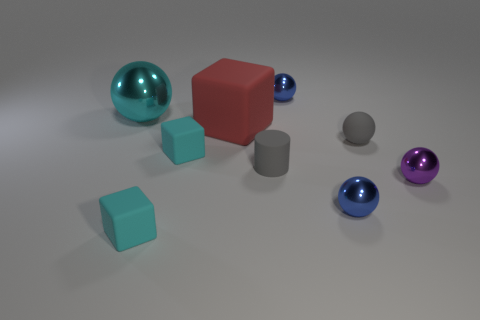Subtract all tiny gray rubber spheres. How many spheres are left? 4 Subtract all cyan balls. How many balls are left? 4 Subtract all yellow spheres. Subtract all brown cylinders. How many spheres are left? 5 Subtract all cubes. How many objects are left? 6 Add 1 red blocks. How many objects exist? 10 Subtract all large blue shiny things. Subtract all large cyan balls. How many objects are left? 8 Add 3 blue metal spheres. How many blue metal spheres are left? 5 Add 5 small yellow blocks. How many small yellow blocks exist? 5 Subtract 1 purple balls. How many objects are left? 8 